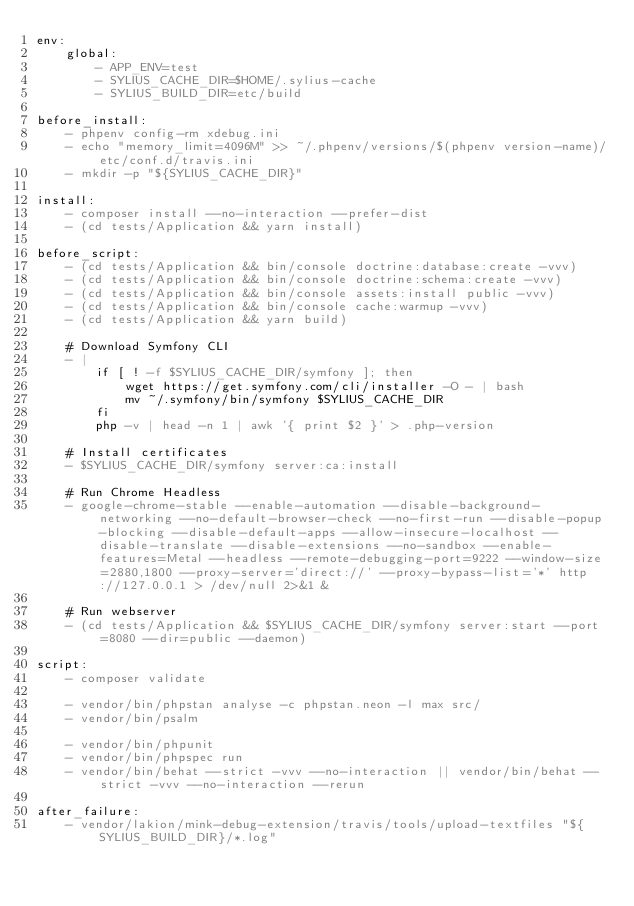Convert code to text. <code><loc_0><loc_0><loc_500><loc_500><_YAML_>env:
    global:
        - APP_ENV=test
        - SYLIUS_CACHE_DIR=$HOME/.sylius-cache
        - SYLIUS_BUILD_DIR=etc/build

before_install:
    - phpenv config-rm xdebug.ini
    - echo "memory_limit=4096M" >> ~/.phpenv/versions/$(phpenv version-name)/etc/conf.d/travis.ini
    - mkdir -p "${SYLIUS_CACHE_DIR}"

install:
    - composer install --no-interaction --prefer-dist
    - (cd tests/Application && yarn install)

before_script:
    - (cd tests/Application && bin/console doctrine:database:create -vvv)
    - (cd tests/Application && bin/console doctrine:schema:create -vvv)
    - (cd tests/Application && bin/console assets:install public -vvv)
    - (cd tests/Application && bin/console cache:warmup -vvv)
    - (cd tests/Application && yarn build)

    # Download Symfony CLI
    - |
        if [ ! -f $SYLIUS_CACHE_DIR/symfony ]; then
            wget https://get.symfony.com/cli/installer -O - | bash
            mv ~/.symfony/bin/symfony $SYLIUS_CACHE_DIR
        fi
        php -v | head -n 1 | awk '{ print $2 }' > .php-version

    # Install certificates
    - $SYLIUS_CACHE_DIR/symfony server:ca:install

    # Run Chrome Headless
    - google-chrome-stable --enable-automation --disable-background-networking --no-default-browser-check --no-first-run --disable-popup-blocking --disable-default-apps --allow-insecure-localhost --disable-translate --disable-extensions --no-sandbox --enable-features=Metal --headless --remote-debugging-port=9222 --window-size=2880,1800 --proxy-server='direct://' --proxy-bypass-list='*' http://127.0.0.1 > /dev/null 2>&1 &

    # Run webserver
    - (cd tests/Application && $SYLIUS_CACHE_DIR/symfony server:start --port=8080 --dir=public --daemon)

script:
    - composer validate

    - vendor/bin/phpstan analyse -c phpstan.neon -l max src/
    - vendor/bin/psalm

    - vendor/bin/phpunit
    - vendor/bin/phpspec run
    - vendor/bin/behat --strict -vvv --no-interaction || vendor/bin/behat --strict -vvv --no-interaction --rerun

after_failure:
    - vendor/lakion/mink-debug-extension/travis/tools/upload-textfiles "${SYLIUS_BUILD_DIR}/*.log"
</code> 